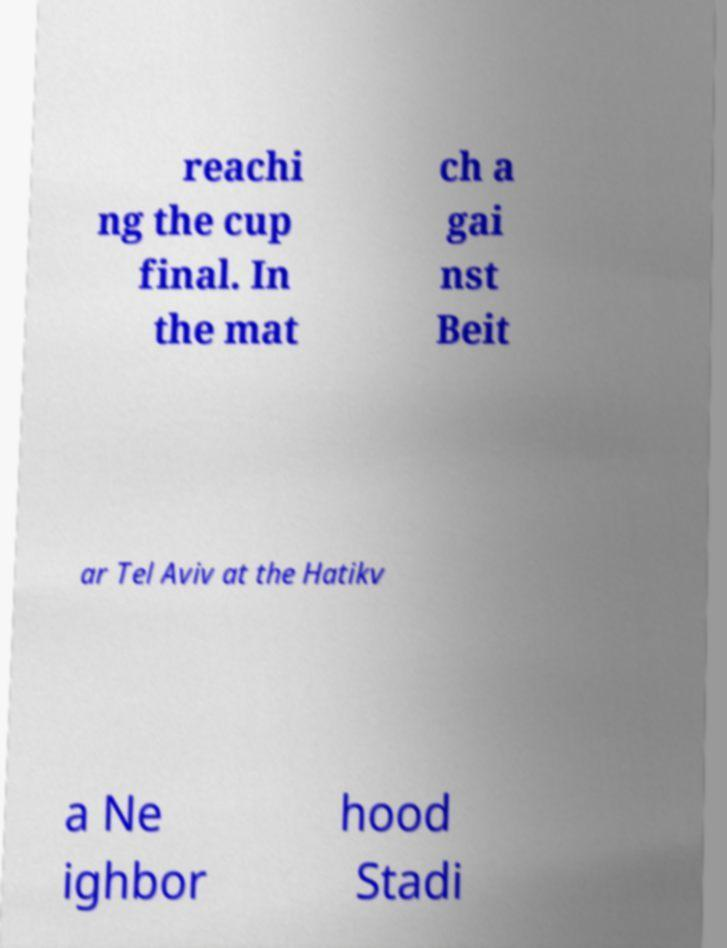Please identify and transcribe the text found in this image. reachi ng the cup final. In the mat ch a gai nst Beit ar Tel Aviv at the Hatikv a Ne ighbor hood Stadi 